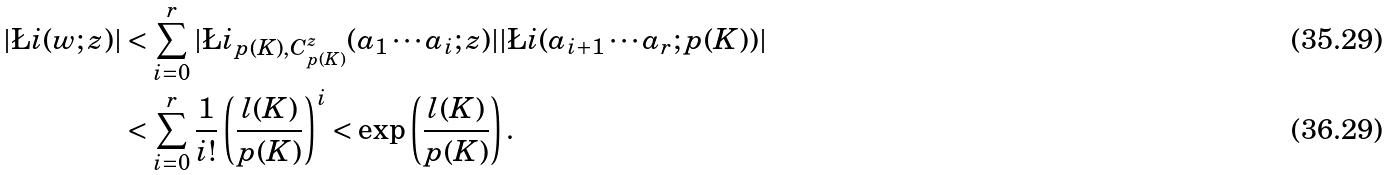<formula> <loc_0><loc_0><loc_500><loc_500>| \L i ( w ; z ) | & < \sum _ { i = 0 } ^ { r } | \L i _ { p ( K ) , C _ { p ( K ) } ^ { z } } ( a _ { 1 } \cdots a _ { i } ; z ) | | \L i ( a _ { i + 1 } \cdots a _ { r } ; p ( K ) ) | \\ & < \sum _ { i = 0 } ^ { r } \frac { 1 } { i ! } \left ( \frac { l ( K ) } { p ( K ) } \right ) ^ { i } < \exp \left ( \frac { l ( K ) } { p ( K ) } \right ) .</formula> 